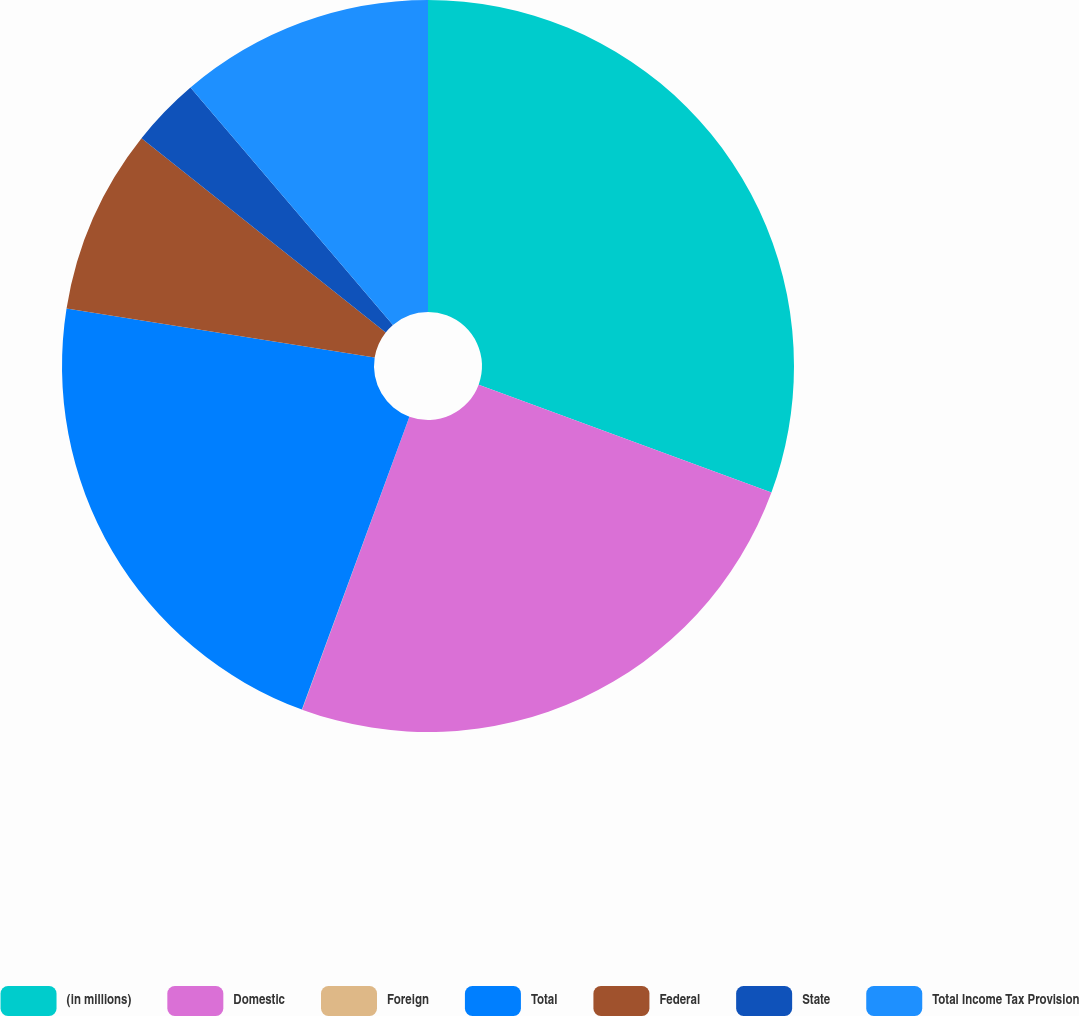Convert chart. <chart><loc_0><loc_0><loc_500><loc_500><pie_chart><fcel>(in millions)<fcel>Domestic<fcel>Foreign<fcel>Total<fcel>Federal<fcel>State<fcel>Total Income Tax Provision<nl><fcel>30.62%<fcel>24.97%<fcel>0.01%<fcel>21.91%<fcel>8.18%<fcel>3.07%<fcel>11.24%<nl></chart> 